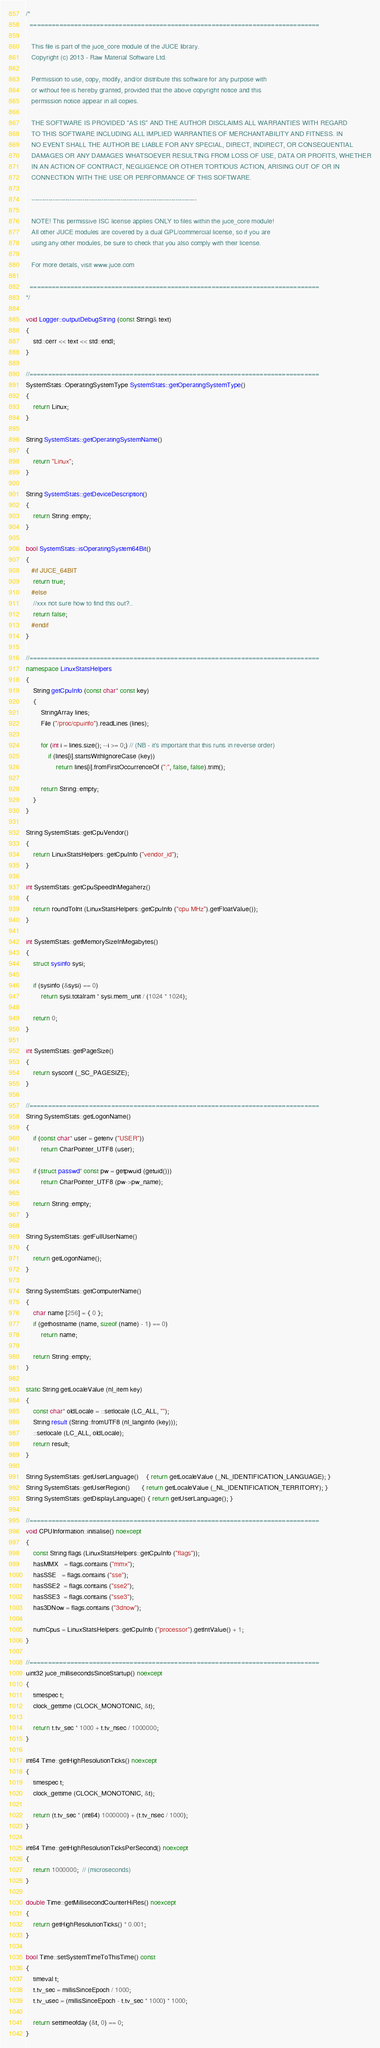<code> <loc_0><loc_0><loc_500><loc_500><_C++_>/*
  ==============================================================================

   This file is part of the juce_core module of the JUCE library.
   Copyright (c) 2013 - Raw Material Software Ltd.

   Permission to use, copy, modify, and/or distribute this software for any purpose with
   or without fee is hereby granted, provided that the above copyright notice and this
   permission notice appear in all copies.

   THE SOFTWARE IS PROVIDED "AS IS" AND THE AUTHOR DISCLAIMS ALL WARRANTIES WITH REGARD
   TO THIS SOFTWARE INCLUDING ALL IMPLIED WARRANTIES OF MERCHANTABILITY AND FITNESS. IN
   NO EVENT SHALL THE AUTHOR BE LIABLE FOR ANY SPECIAL, DIRECT, INDIRECT, OR CONSEQUENTIAL
   DAMAGES OR ANY DAMAGES WHATSOEVER RESULTING FROM LOSS OF USE, DATA OR PROFITS, WHETHER
   IN AN ACTION OF CONTRACT, NEGLIGENCE OR OTHER TORTIOUS ACTION, ARISING OUT OF OR IN
   CONNECTION WITH THE USE OR PERFORMANCE OF THIS SOFTWARE.

   ------------------------------------------------------------------------------

   NOTE! This permissive ISC license applies ONLY to files within the juce_core module!
   All other JUCE modules are covered by a dual GPL/commercial license, so if you are
   using any other modules, be sure to check that you also comply with their license.

   For more details, visit www.juce.com

  ==============================================================================
*/

void Logger::outputDebugString (const String& text)
{
    std::cerr << text << std::endl;
}

//==============================================================================
SystemStats::OperatingSystemType SystemStats::getOperatingSystemType()
{
    return Linux;
}

String SystemStats::getOperatingSystemName()
{
    return "Linux";
}

String SystemStats::getDeviceDescription()
{
    return String::empty;
}

bool SystemStats::isOperatingSystem64Bit()
{
   #if JUCE_64BIT
    return true;
   #else
    //xxx not sure how to find this out?..
    return false;
   #endif
}

//==============================================================================
namespace LinuxStatsHelpers
{
    String getCpuInfo (const char* const key)
    {
        StringArray lines;
        File ("/proc/cpuinfo").readLines (lines);

        for (int i = lines.size(); --i >= 0;) // (NB - it's important that this runs in reverse order)
            if (lines[i].startsWithIgnoreCase (key))
                return lines[i].fromFirstOccurrenceOf (":", false, false).trim();

        return String::empty;
    }
}

String SystemStats::getCpuVendor()
{
    return LinuxStatsHelpers::getCpuInfo ("vendor_id");
}

int SystemStats::getCpuSpeedInMegaherz()
{
    return roundToInt (LinuxStatsHelpers::getCpuInfo ("cpu MHz").getFloatValue());
}

int SystemStats::getMemorySizeInMegabytes()
{
    struct sysinfo sysi;

    if (sysinfo (&sysi) == 0)
        return sysi.totalram * sysi.mem_unit / (1024 * 1024);

    return 0;
}

int SystemStats::getPageSize()
{
    return sysconf (_SC_PAGESIZE);
}

//==============================================================================
String SystemStats::getLogonName()
{
    if (const char* user = getenv ("USER"))
        return CharPointer_UTF8 (user);

    if (struct passwd* const pw = getpwuid (getuid()))
        return CharPointer_UTF8 (pw->pw_name);

    return String::empty;
}

String SystemStats::getFullUserName()
{
    return getLogonName();
}

String SystemStats::getComputerName()
{
    char name [256] = { 0 };
    if (gethostname (name, sizeof (name) - 1) == 0)
        return name;

    return String::empty;
}

static String getLocaleValue (nl_item key)
{
    const char* oldLocale = ::setlocale (LC_ALL, "");
    String result (String::fromUTF8 (nl_langinfo (key)));
    ::setlocale (LC_ALL, oldLocale);
    return result;
}

String SystemStats::getUserLanguage()    { return getLocaleValue (_NL_IDENTIFICATION_LANGUAGE); }
String SystemStats::getUserRegion()      { return getLocaleValue (_NL_IDENTIFICATION_TERRITORY); }
String SystemStats::getDisplayLanguage() { return getUserLanguage(); }

//==============================================================================
void CPUInformation::initialise() noexcept
{
    const String flags (LinuxStatsHelpers::getCpuInfo ("flags"));
    hasMMX   = flags.contains ("mmx");
    hasSSE   = flags.contains ("sse");
    hasSSE2  = flags.contains ("sse2");
    hasSSE3  = flags.contains ("sse3");
    has3DNow = flags.contains ("3dnow");

    numCpus = LinuxStatsHelpers::getCpuInfo ("processor").getIntValue() + 1;
}

//==============================================================================
uint32 juce_millisecondsSinceStartup() noexcept
{
    timespec t;
    clock_gettime (CLOCK_MONOTONIC, &t);

    return t.tv_sec * 1000 + t.tv_nsec / 1000000;
}

int64 Time::getHighResolutionTicks() noexcept
{
    timespec t;
    clock_gettime (CLOCK_MONOTONIC, &t);

    return (t.tv_sec * (int64) 1000000) + (t.tv_nsec / 1000);
}

int64 Time::getHighResolutionTicksPerSecond() noexcept
{
    return 1000000;  // (microseconds)
}

double Time::getMillisecondCounterHiRes() noexcept
{
    return getHighResolutionTicks() * 0.001;
}

bool Time::setSystemTimeToThisTime() const
{
    timeval t;
    t.tv_sec = millisSinceEpoch / 1000;
    t.tv_usec = (millisSinceEpoch - t.tv_sec * 1000) * 1000;

    return settimeofday (&t, 0) == 0;
}
</code> 